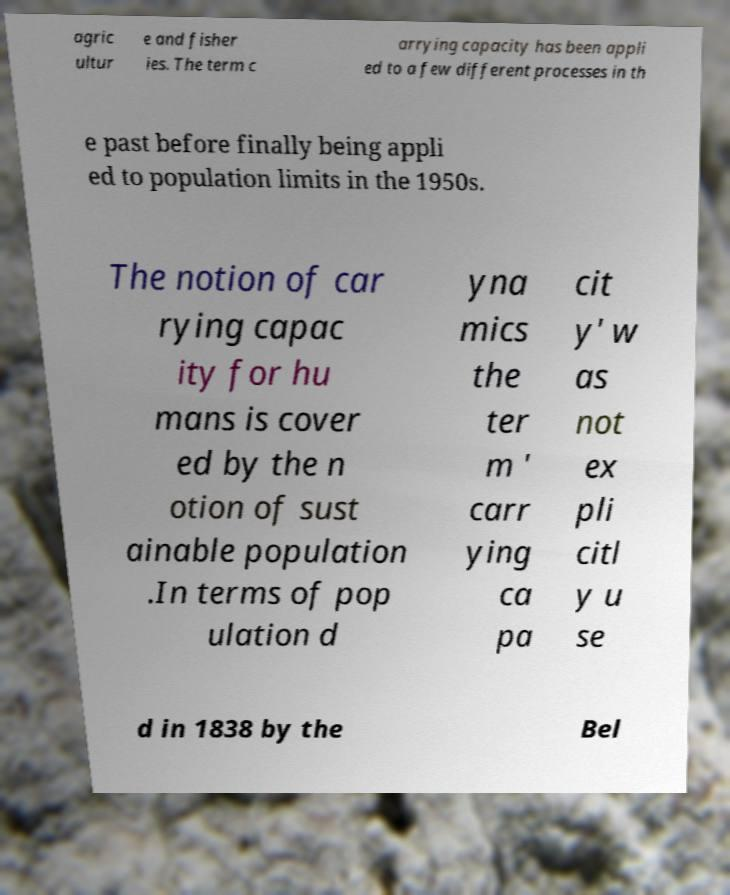Can you read and provide the text displayed in the image?This photo seems to have some interesting text. Can you extract and type it out for me? agric ultur e and fisher ies. The term c arrying capacity has been appli ed to a few different processes in th e past before finally being appli ed to population limits in the 1950s. The notion of car rying capac ity for hu mans is cover ed by the n otion of sust ainable population .In terms of pop ulation d yna mics the ter m ' carr ying ca pa cit y' w as not ex pli citl y u se d in 1838 by the Bel 